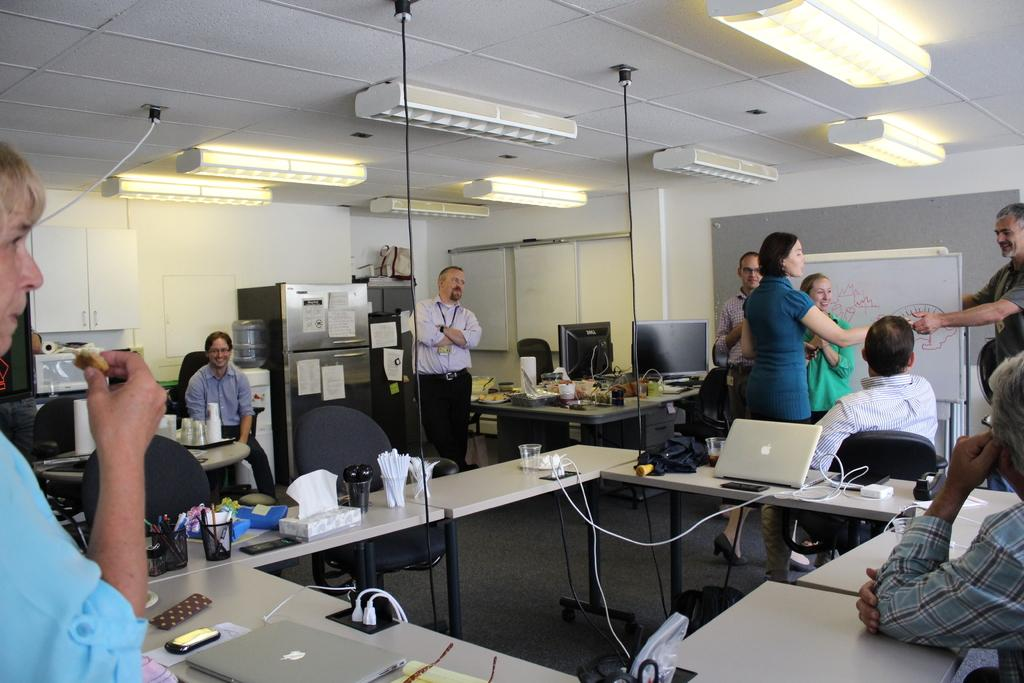How many people are in the image? There are people in the image, but the exact number is not specified. What are the people doing in the image? Some people are sitting on chairs, while others are standing. What color are the clothes worn by the standing people? The standing people are wearing red. What type of furniture is present in the image? There are tables in the image. What electronic devices can be seen on the tables? There are laptops on the tables. What type of beverage container is present on the tables? There are glasses on the tables. What other items can be found on the tables? There are additional items on the tables, but their specific nature is not mentioned. How many facts can be seen in the image? There are no facts visible in the image, as facts are not physical objects that can be seen. 